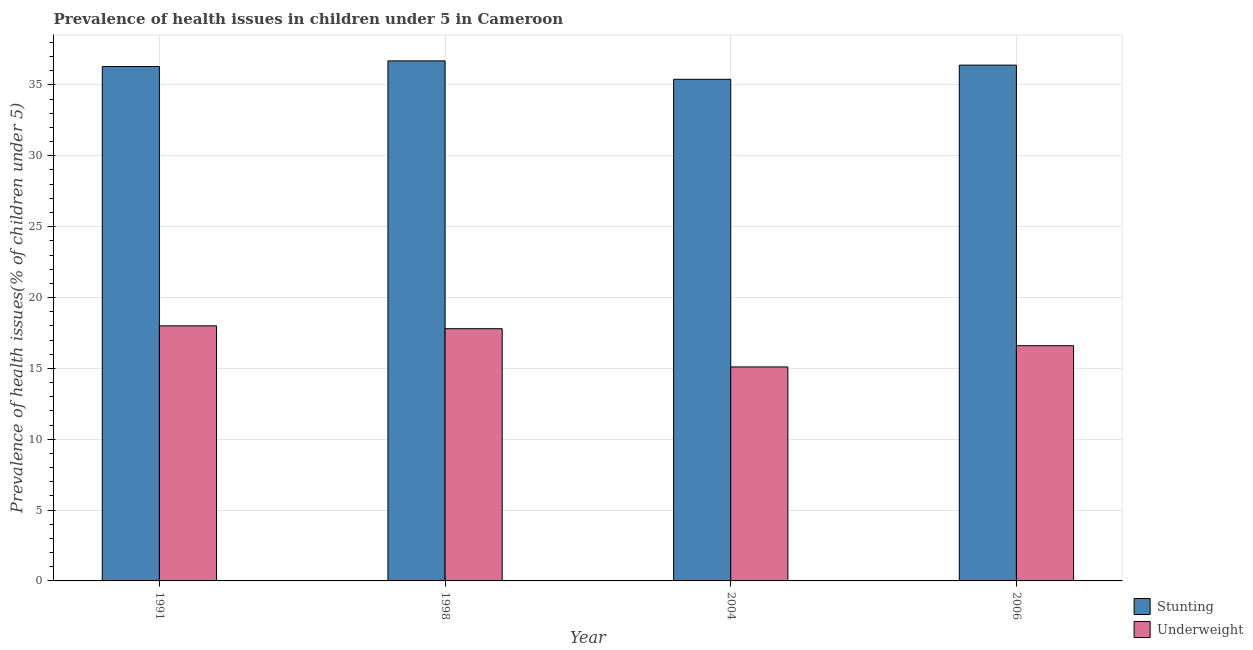How many bars are there on the 1st tick from the right?
Your answer should be very brief. 2. In how many cases, is the number of bars for a given year not equal to the number of legend labels?
Offer a very short reply. 0. What is the percentage of underweight children in 2006?
Offer a terse response. 16.6. Across all years, what is the maximum percentage of underweight children?
Give a very brief answer. 18. Across all years, what is the minimum percentage of underweight children?
Provide a short and direct response. 15.1. What is the total percentage of underweight children in the graph?
Your answer should be very brief. 67.5. What is the difference between the percentage of underweight children in 1998 and that in 2004?
Offer a very short reply. 2.7. What is the difference between the percentage of underweight children in 1991 and the percentage of stunted children in 1998?
Your answer should be very brief. 0.2. What is the average percentage of underweight children per year?
Provide a succinct answer. 16.87. In the year 2004, what is the difference between the percentage of underweight children and percentage of stunted children?
Your response must be concise. 0. What is the ratio of the percentage of underweight children in 2004 to that in 2006?
Offer a terse response. 0.91. What is the difference between the highest and the second highest percentage of stunted children?
Make the answer very short. 0.3. What is the difference between the highest and the lowest percentage of underweight children?
Provide a short and direct response. 2.9. What does the 2nd bar from the left in 1998 represents?
Provide a succinct answer. Underweight. What does the 1st bar from the right in 1998 represents?
Your answer should be very brief. Underweight. Are all the bars in the graph horizontal?
Make the answer very short. No. How many years are there in the graph?
Make the answer very short. 4. Does the graph contain any zero values?
Your answer should be compact. No. Where does the legend appear in the graph?
Give a very brief answer. Bottom right. What is the title of the graph?
Keep it short and to the point. Prevalence of health issues in children under 5 in Cameroon. What is the label or title of the X-axis?
Your response must be concise. Year. What is the label or title of the Y-axis?
Give a very brief answer. Prevalence of health issues(% of children under 5). What is the Prevalence of health issues(% of children under 5) of Stunting in 1991?
Provide a succinct answer. 36.3. What is the Prevalence of health issues(% of children under 5) of Stunting in 1998?
Give a very brief answer. 36.7. What is the Prevalence of health issues(% of children under 5) in Underweight in 1998?
Offer a terse response. 17.8. What is the Prevalence of health issues(% of children under 5) in Stunting in 2004?
Make the answer very short. 35.4. What is the Prevalence of health issues(% of children under 5) of Underweight in 2004?
Give a very brief answer. 15.1. What is the Prevalence of health issues(% of children under 5) in Stunting in 2006?
Offer a very short reply. 36.4. What is the Prevalence of health issues(% of children under 5) in Underweight in 2006?
Your answer should be compact. 16.6. Across all years, what is the maximum Prevalence of health issues(% of children under 5) of Stunting?
Your answer should be very brief. 36.7. Across all years, what is the maximum Prevalence of health issues(% of children under 5) in Underweight?
Keep it short and to the point. 18. Across all years, what is the minimum Prevalence of health issues(% of children under 5) in Stunting?
Provide a short and direct response. 35.4. Across all years, what is the minimum Prevalence of health issues(% of children under 5) in Underweight?
Your answer should be very brief. 15.1. What is the total Prevalence of health issues(% of children under 5) in Stunting in the graph?
Your answer should be compact. 144.8. What is the total Prevalence of health issues(% of children under 5) of Underweight in the graph?
Offer a terse response. 67.5. What is the difference between the Prevalence of health issues(% of children under 5) of Stunting in 1991 and that in 1998?
Provide a succinct answer. -0.4. What is the difference between the Prevalence of health issues(% of children under 5) in Stunting in 1991 and that in 2004?
Your answer should be compact. 0.9. What is the difference between the Prevalence of health issues(% of children under 5) in Underweight in 1991 and that in 2004?
Your answer should be compact. 2.9. What is the difference between the Prevalence of health issues(% of children under 5) of Underweight in 1991 and that in 2006?
Offer a terse response. 1.4. What is the difference between the Prevalence of health issues(% of children under 5) of Stunting in 1998 and that in 2004?
Offer a terse response. 1.3. What is the difference between the Prevalence of health issues(% of children under 5) of Underweight in 1998 and that in 2004?
Offer a terse response. 2.7. What is the difference between the Prevalence of health issues(% of children under 5) of Underweight in 1998 and that in 2006?
Give a very brief answer. 1.2. What is the difference between the Prevalence of health issues(% of children under 5) in Stunting in 2004 and that in 2006?
Your answer should be very brief. -1. What is the difference between the Prevalence of health issues(% of children under 5) in Underweight in 2004 and that in 2006?
Your answer should be compact. -1.5. What is the difference between the Prevalence of health issues(% of children under 5) of Stunting in 1991 and the Prevalence of health issues(% of children under 5) of Underweight in 1998?
Offer a terse response. 18.5. What is the difference between the Prevalence of health issues(% of children under 5) in Stunting in 1991 and the Prevalence of health issues(% of children under 5) in Underweight in 2004?
Give a very brief answer. 21.2. What is the difference between the Prevalence of health issues(% of children under 5) of Stunting in 1998 and the Prevalence of health issues(% of children under 5) of Underweight in 2004?
Make the answer very short. 21.6. What is the difference between the Prevalence of health issues(% of children under 5) in Stunting in 1998 and the Prevalence of health issues(% of children under 5) in Underweight in 2006?
Ensure brevity in your answer.  20.1. What is the difference between the Prevalence of health issues(% of children under 5) in Stunting in 2004 and the Prevalence of health issues(% of children under 5) in Underweight in 2006?
Provide a succinct answer. 18.8. What is the average Prevalence of health issues(% of children under 5) in Stunting per year?
Keep it short and to the point. 36.2. What is the average Prevalence of health issues(% of children under 5) in Underweight per year?
Your response must be concise. 16.88. In the year 1998, what is the difference between the Prevalence of health issues(% of children under 5) in Stunting and Prevalence of health issues(% of children under 5) in Underweight?
Give a very brief answer. 18.9. In the year 2004, what is the difference between the Prevalence of health issues(% of children under 5) of Stunting and Prevalence of health issues(% of children under 5) of Underweight?
Provide a succinct answer. 20.3. In the year 2006, what is the difference between the Prevalence of health issues(% of children under 5) of Stunting and Prevalence of health issues(% of children under 5) of Underweight?
Offer a terse response. 19.8. What is the ratio of the Prevalence of health issues(% of children under 5) of Stunting in 1991 to that in 1998?
Ensure brevity in your answer.  0.99. What is the ratio of the Prevalence of health issues(% of children under 5) in Underweight in 1991 to that in 1998?
Provide a succinct answer. 1.01. What is the ratio of the Prevalence of health issues(% of children under 5) in Stunting in 1991 to that in 2004?
Ensure brevity in your answer.  1.03. What is the ratio of the Prevalence of health issues(% of children under 5) of Underweight in 1991 to that in 2004?
Keep it short and to the point. 1.19. What is the ratio of the Prevalence of health issues(% of children under 5) of Underweight in 1991 to that in 2006?
Your answer should be very brief. 1.08. What is the ratio of the Prevalence of health issues(% of children under 5) of Stunting in 1998 to that in 2004?
Your answer should be compact. 1.04. What is the ratio of the Prevalence of health issues(% of children under 5) in Underweight in 1998 to that in 2004?
Offer a terse response. 1.18. What is the ratio of the Prevalence of health issues(% of children under 5) of Stunting in 1998 to that in 2006?
Make the answer very short. 1.01. What is the ratio of the Prevalence of health issues(% of children under 5) in Underweight in 1998 to that in 2006?
Ensure brevity in your answer.  1.07. What is the ratio of the Prevalence of health issues(% of children under 5) in Stunting in 2004 to that in 2006?
Ensure brevity in your answer.  0.97. What is the ratio of the Prevalence of health issues(% of children under 5) of Underweight in 2004 to that in 2006?
Keep it short and to the point. 0.91. What is the difference between the highest and the second highest Prevalence of health issues(% of children under 5) in Underweight?
Ensure brevity in your answer.  0.2. What is the difference between the highest and the lowest Prevalence of health issues(% of children under 5) of Stunting?
Provide a succinct answer. 1.3. 